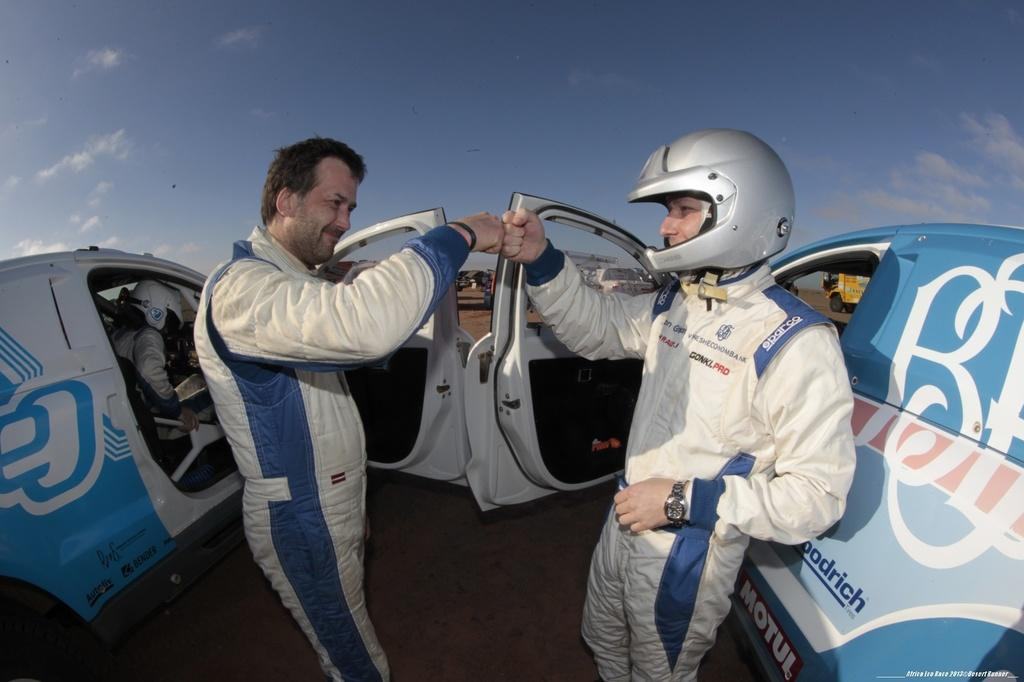How many people are present in the image? There are two persons present in the image. What are the people doing in the image? One person is standing, and another person is sitting in a vehicle. What type of vehicle is beside the standing person? There is a vehicle beside one of the persons. What safety precaution is the person in the vehicle taking? The person in the vehicle is wearing a helmet. What is the color of the sky in the image? The sky is blue in the image. Are both standing persons wearing helmets? Yes, both standing persons are wearing helmets. What type of leather is being used to make the beef in the image? There is no leather or beef present in the image. How many books can be seen on the table in the image? There is no table or books present in the image. 